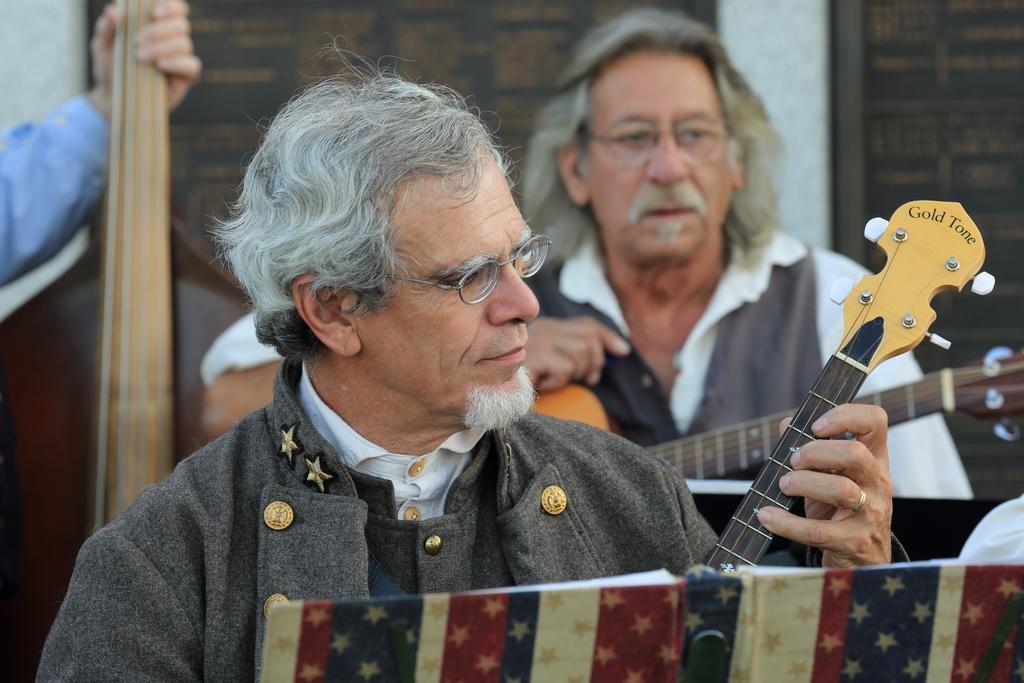How many people are in the image? There are two men in the image. What are the men holding in the image? The men are holding guitars. What objects are in front of the men? There are books in front of the men. Can you describe the background of the image? There is a person and a wall in the background of the image. What type of loaf can be seen on the tray in the image? There is no tray or loaf present in the image. What flavor of soda is the person in the background drinking? There is no soda or person drinking in the image. 